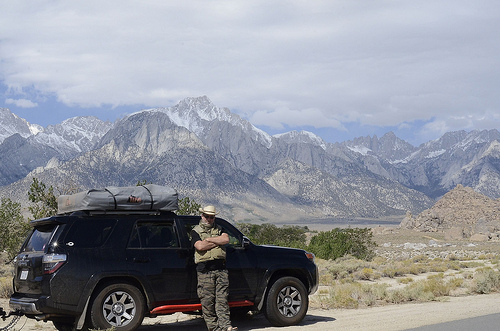<image>
Is there a car to the left of the man? Yes. From this viewpoint, the car is positioned to the left side relative to the man. 